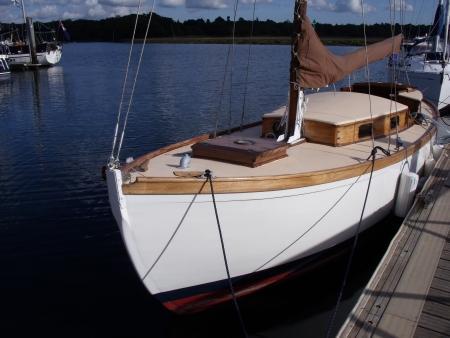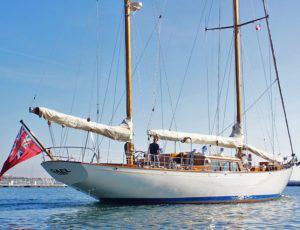The first image is the image on the left, the second image is the image on the right. Assess this claim about the two images: "A sailboat in one image has white billowing sails, but the sails of a boat in the other image are furled.". Correct or not? Answer yes or no. No. 